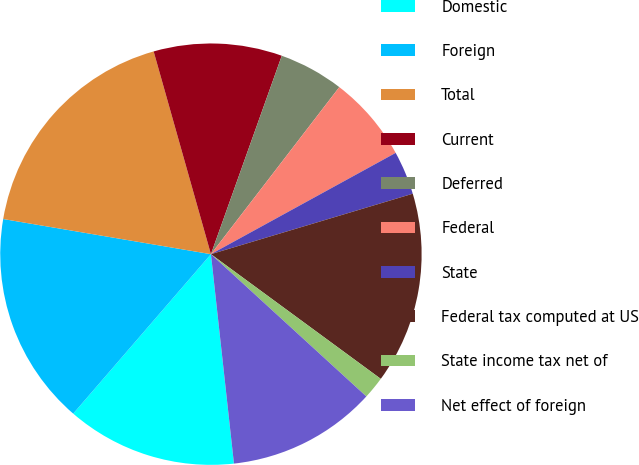Convert chart to OTSL. <chart><loc_0><loc_0><loc_500><loc_500><pie_chart><fcel>Domestic<fcel>Foreign<fcel>Total<fcel>Current<fcel>Deferred<fcel>Federal<fcel>State<fcel>Federal tax computed at US<fcel>State income tax net of<fcel>Net effect of foreign<nl><fcel>13.08%<fcel>16.33%<fcel>17.95%<fcel>9.84%<fcel>4.97%<fcel>6.59%<fcel>3.35%<fcel>14.71%<fcel>1.72%<fcel>11.46%<nl></chart> 